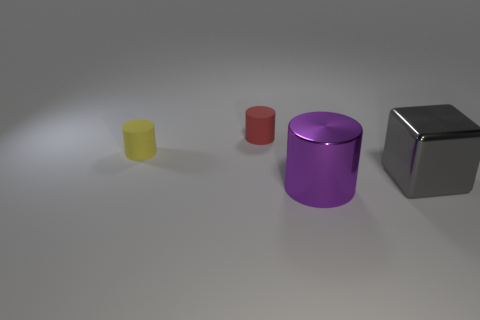What material is the object that is behind the big purple thing and in front of the yellow thing? metal 